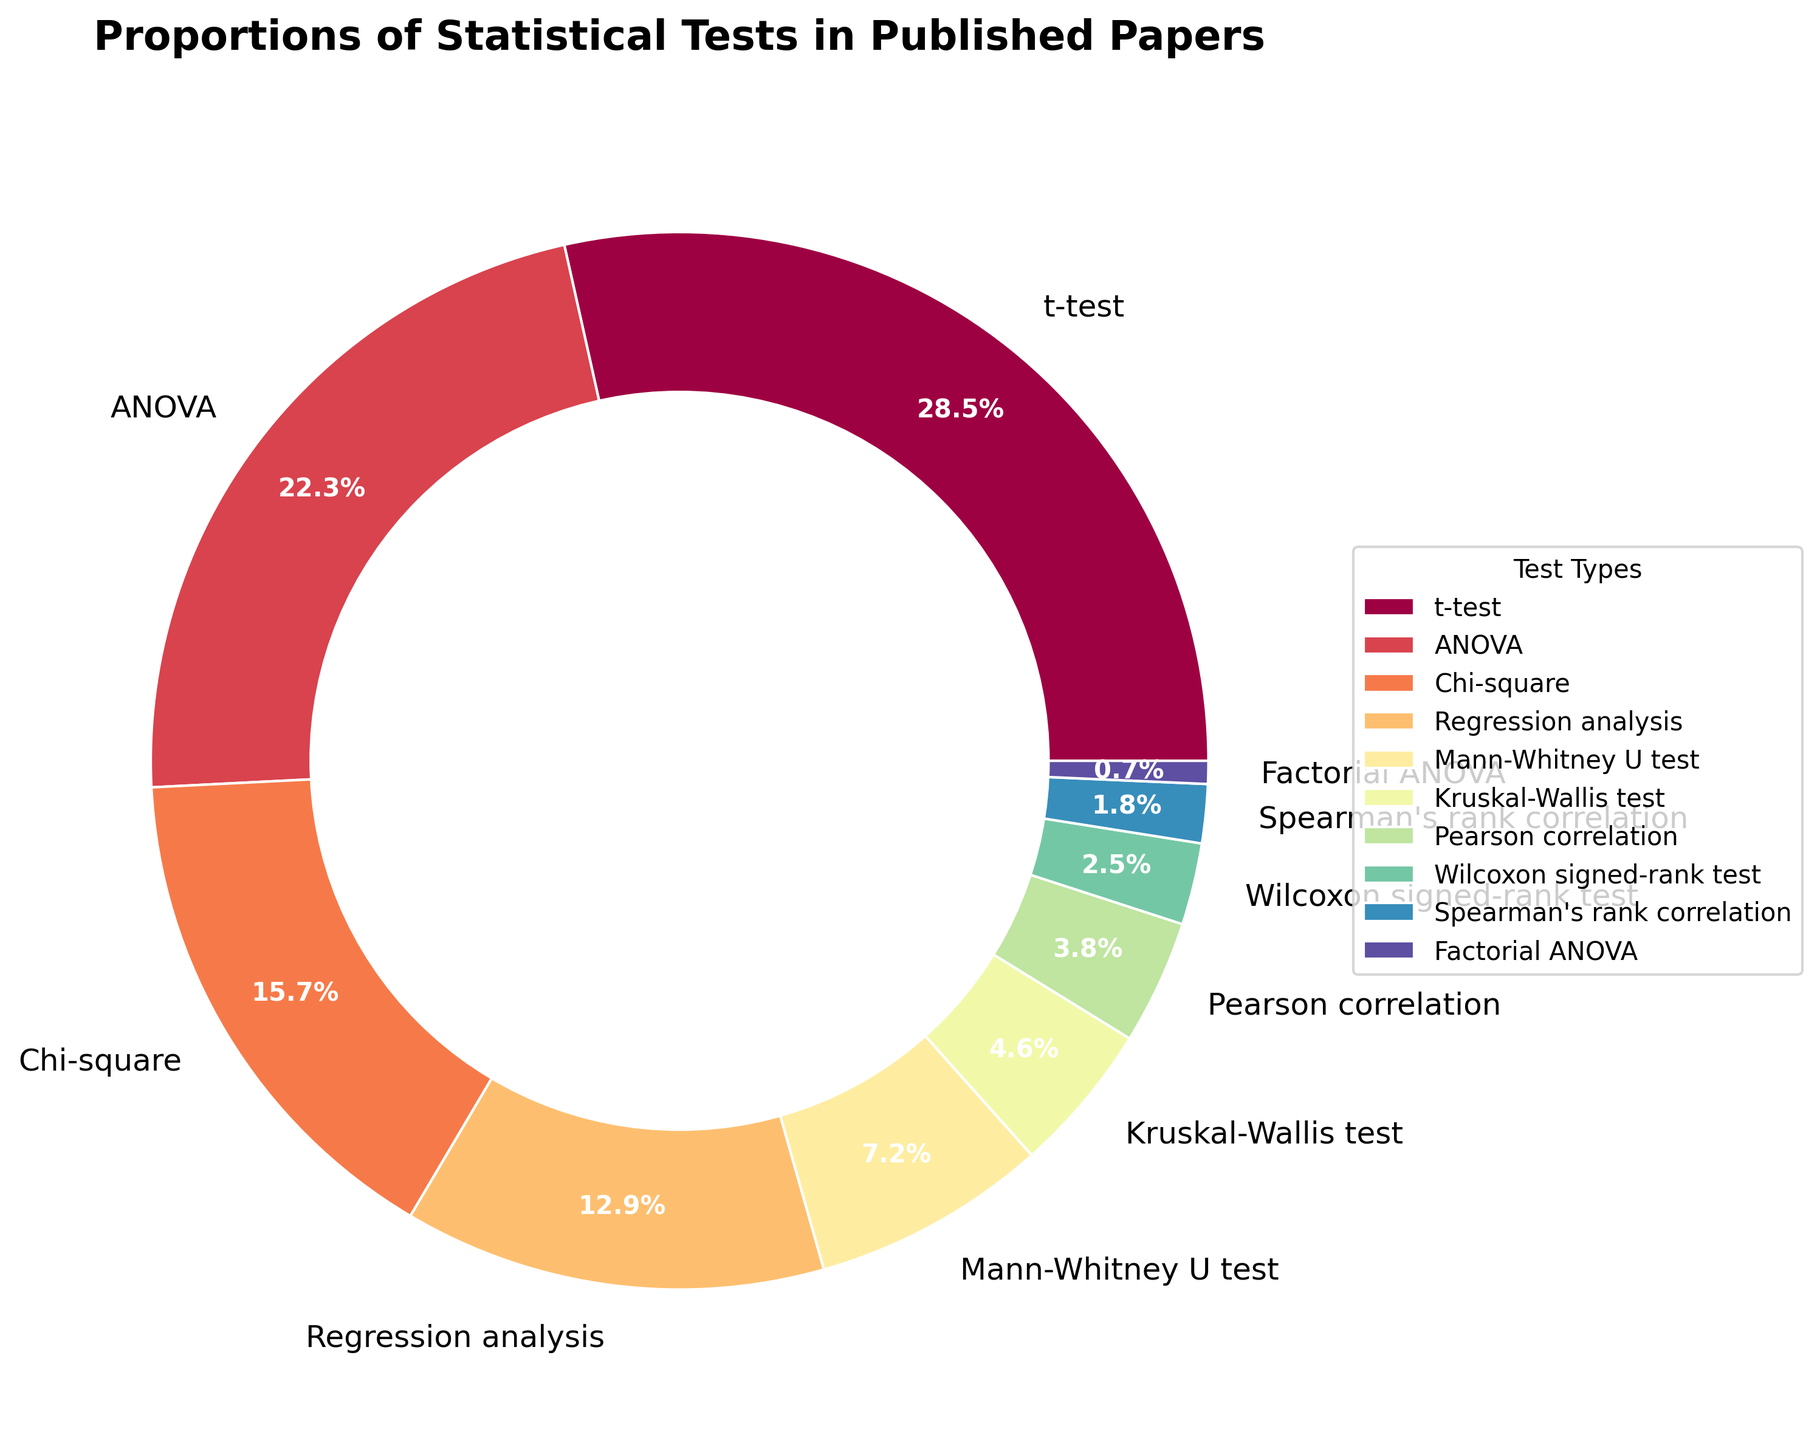What is the most frequently used statistical test according to the chart? The pie chart shows the proportions of different statistical tests, and the largest wedge corresponds to the 't-test' with 28.5%.
Answer: t-test What is the difference in percentage between the most and least used statistical tests? The most used test is the 't-test' with 28.5%, and the least used is the 'Factorial ANOVA' with 0.7%. The difference is 28.5% - 0.7% = 27.8%.
Answer: 27.8% Which statistical tests together make up more than half of the total usage? The tests are 't-test' (28.5%), 'ANOVA' (22.3%), and 'Chi-square' (15.7%). Adding these percentages: 28.5% + 22.3% + 15.7% = 66.5%, which is more than half (50%).
Answer: t-test, ANOVA, Chi-square What is the combined percentage of non-parametric tests (Mann-Whitney U test, Kruskal-Wallis test, Wilcoxon signed-rank test, Spearman's rank correlation)? Summing percentages of Mann-Whitney U test (7.2%), Kruskal-Wallis test (4.6%), Wilcoxon signed-rank test (2.5%), and Spearman's rank correlation (1.8%): 7.2% + 4.6% + 2.5% + 1.8% = 16.1%.
Answer: 16.1% Compare the usage percentage of 'ANOVA' and 'Regression analysis'. Which one is higher and by how much? 'ANOVA' has a percentage of 22.3%, while 'Regression analysis' has 12.9%. The difference is 22.3% - 12.9% = 9.4%, with 'ANOVA' being higher.
Answer: ANOVA by 9.4% Which statistical test shares the same wedge color with 'Chi-square'? By observing the pie chart, each test type is colored differently. To determine the color, one must identify the corresponding section in the chart. The 'Chi-square' test has its unique color that is not shared with any other test in the chart.
Answer: None What percentage of statistical tests are parametric (t-test, ANOVA, Regression analysis, Pearson correlation, Factorial ANOVA)? Summing percentages of t-test (28.5%), ANOVA (22.3%), Regression analysis (12.9%), Pearson correlation (3.8%), and Factorial ANOVA (0.7%): 28.5% + 22.3% + 12.9% + 3.8% + 0.7% = 68.2%.
Answer: 68.2% Which test has a lower percentage, Mann-Whitney U test or Kruskal-Wallis test, and by how much? Mann-Whitney U test has 7.2%, Kruskal-Wallis test has 4.6%. The difference is 7.2% - 4.6% = 2.6%. The Mann-Whitney U test is higher.
Answer: Kruskal-Wallis by 2.6% What is the sum of the least three used statistical tests? The least three used statistical tests are 'Kruskal-Wallis test' (4.6%), 'Wilcoxon signed-rank test' (2.5%), and 'Spearman's rank correlation' (1.8%). Summing these: 4.6% + 2.5% + 1.8% = 8.9%.
Answer: 8.9% 